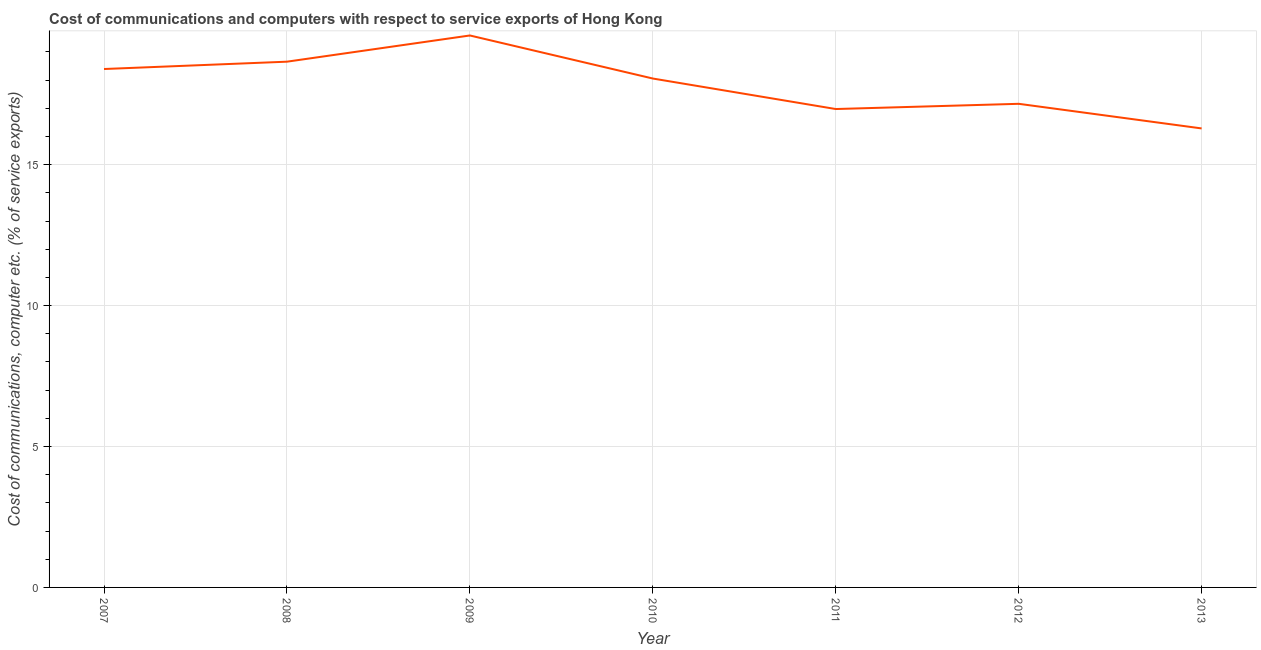What is the cost of communications and computer in 2007?
Your response must be concise. 18.39. Across all years, what is the maximum cost of communications and computer?
Provide a succinct answer. 19.58. Across all years, what is the minimum cost of communications and computer?
Make the answer very short. 16.28. In which year was the cost of communications and computer minimum?
Your answer should be very brief. 2013. What is the sum of the cost of communications and computer?
Your response must be concise. 125.1. What is the difference between the cost of communications and computer in 2007 and 2013?
Your answer should be very brief. 2.11. What is the average cost of communications and computer per year?
Provide a short and direct response. 17.87. What is the median cost of communications and computer?
Keep it short and to the point. 18.06. Do a majority of the years between 2013 and 2007 (inclusive) have cost of communications and computer greater than 3 %?
Your response must be concise. Yes. What is the ratio of the cost of communications and computer in 2011 to that in 2013?
Offer a terse response. 1.04. What is the difference between the highest and the second highest cost of communications and computer?
Your response must be concise. 0.93. What is the difference between the highest and the lowest cost of communications and computer?
Your answer should be compact. 3.3. In how many years, is the cost of communications and computer greater than the average cost of communications and computer taken over all years?
Your answer should be compact. 4. Does the cost of communications and computer monotonically increase over the years?
Provide a short and direct response. No. How many years are there in the graph?
Provide a succinct answer. 7. Does the graph contain grids?
Provide a short and direct response. Yes. What is the title of the graph?
Give a very brief answer. Cost of communications and computers with respect to service exports of Hong Kong. What is the label or title of the Y-axis?
Your response must be concise. Cost of communications, computer etc. (% of service exports). What is the Cost of communications, computer etc. (% of service exports) of 2007?
Provide a succinct answer. 18.39. What is the Cost of communications, computer etc. (% of service exports) of 2008?
Offer a terse response. 18.65. What is the Cost of communications, computer etc. (% of service exports) of 2009?
Provide a succinct answer. 19.58. What is the Cost of communications, computer etc. (% of service exports) in 2010?
Offer a very short reply. 18.06. What is the Cost of communications, computer etc. (% of service exports) of 2011?
Your response must be concise. 16.97. What is the Cost of communications, computer etc. (% of service exports) in 2012?
Provide a short and direct response. 17.16. What is the Cost of communications, computer etc. (% of service exports) of 2013?
Your response must be concise. 16.28. What is the difference between the Cost of communications, computer etc. (% of service exports) in 2007 and 2008?
Your response must be concise. -0.26. What is the difference between the Cost of communications, computer etc. (% of service exports) in 2007 and 2009?
Ensure brevity in your answer.  -1.19. What is the difference between the Cost of communications, computer etc. (% of service exports) in 2007 and 2010?
Your response must be concise. 0.34. What is the difference between the Cost of communications, computer etc. (% of service exports) in 2007 and 2011?
Provide a short and direct response. 1.42. What is the difference between the Cost of communications, computer etc. (% of service exports) in 2007 and 2012?
Make the answer very short. 1.23. What is the difference between the Cost of communications, computer etc. (% of service exports) in 2007 and 2013?
Keep it short and to the point. 2.11. What is the difference between the Cost of communications, computer etc. (% of service exports) in 2008 and 2009?
Your answer should be compact. -0.93. What is the difference between the Cost of communications, computer etc. (% of service exports) in 2008 and 2010?
Provide a succinct answer. 0.6. What is the difference between the Cost of communications, computer etc. (% of service exports) in 2008 and 2011?
Keep it short and to the point. 1.68. What is the difference between the Cost of communications, computer etc. (% of service exports) in 2008 and 2012?
Keep it short and to the point. 1.49. What is the difference between the Cost of communications, computer etc. (% of service exports) in 2008 and 2013?
Provide a succinct answer. 2.37. What is the difference between the Cost of communications, computer etc. (% of service exports) in 2009 and 2010?
Your answer should be compact. 1.53. What is the difference between the Cost of communications, computer etc. (% of service exports) in 2009 and 2011?
Provide a succinct answer. 2.61. What is the difference between the Cost of communications, computer etc. (% of service exports) in 2009 and 2012?
Provide a short and direct response. 2.42. What is the difference between the Cost of communications, computer etc. (% of service exports) in 2009 and 2013?
Offer a terse response. 3.3. What is the difference between the Cost of communications, computer etc. (% of service exports) in 2010 and 2011?
Provide a succinct answer. 1.08. What is the difference between the Cost of communications, computer etc. (% of service exports) in 2010 and 2012?
Ensure brevity in your answer.  0.9. What is the difference between the Cost of communications, computer etc. (% of service exports) in 2010 and 2013?
Your answer should be compact. 1.77. What is the difference between the Cost of communications, computer etc. (% of service exports) in 2011 and 2012?
Make the answer very short. -0.19. What is the difference between the Cost of communications, computer etc. (% of service exports) in 2011 and 2013?
Offer a terse response. 0.69. What is the difference between the Cost of communications, computer etc. (% of service exports) in 2012 and 2013?
Keep it short and to the point. 0.87. What is the ratio of the Cost of communications, computer etc. (% of service exports) in 2007 to that in 2008?
Your response must be concise. 0.99. What is the ratio of the Cost of communications, computer etc. (% of service exports) in 2007 to that in 2009?
Provide a succinct answer. 0.94. What is the ratio of the Cost of communications, computer etc. (% of service exports) in 2007 to that in 2011?
Provide a succinct answer. 1.08. What is the ratio of the Cost of communications, computer etc. (% of service exports) in 2007 to that in 2012?
Ensure brevity in your answer.  1.07. What is the ratio of the Cost of communications, computer etc. (% of service exports) in 2007 to that in 2013?
Ensure brevity in your answer.  1.13. What is the ratio of the Cost of communications, computer etc. (% of service exports) in 2008 to that in 2009?
Keep it short and to the point. 0.95. What is the ratio of the Cost of communications, computer etc. (% of service exports) in 2008 to that in 2010?
Your response must be concise. 1.03. What is the ratio of the Cost of communications, computer etc. (% of service exports) in 2008 to that in 2011?
Your answer should be compact. 1.1. What is the ratio of the Cost of communications, computer etc. (% of service exports) in 2008 to that in 2012?
Offer a very short reply. 1.09. What is the ratio of the Cost of communications, computer etc. (% of service exports) in 2008 to that in 2013?
Provide a short and direct response. 1.15. What is the ratio of the Cost of communications, computer etc. (% of service exports) in 2009 to that in 2010?
Offer a very short reply. 1.08. What is the ratio of the Cost of communications, computer etc. (% of service exports) in 2009 to that in 2011?
Your response must be concise. 1.15. What is the ratio of the Cost of communications, computer etc. (% of service exports) in 2009 to that in 2012?
Give a very brief answer. 1.14. What is the ratio of the Cost of communications, computer etc. (% of service exports) in 2009 to that in 2013?
Your response must be concise. 1.2. What is the ratio of the Cost of communications, computer etc. (% of service exports) in 2010 to that in 2011?
Your answer should be compact. 1.06. What is the ratio of the Cost of communications, computer etc. (% of service exports) in 2010 to that in 2012?
Offer a terse response. 1.05. What is the ratio of the Cost of communications, computer etc. (% of service exports) in 2010 to that in 2013?
Provide a succinct answer. 1.11. What is the ratio of the Cost of communications, computer etc. (% of service exports) in 2011 to that in 2012?
Offer a very short reply. 0.99. What is the ratio of the Cost of communications, computer etc. (% of service exports) in 2011 to that in 2013?
Your answer should be compact. 1.04. What is the ratio of the Cost of communications, computer etc. (% of service exports) in 2012 to that in 2013?
Give a very brief answer. 1.05. 